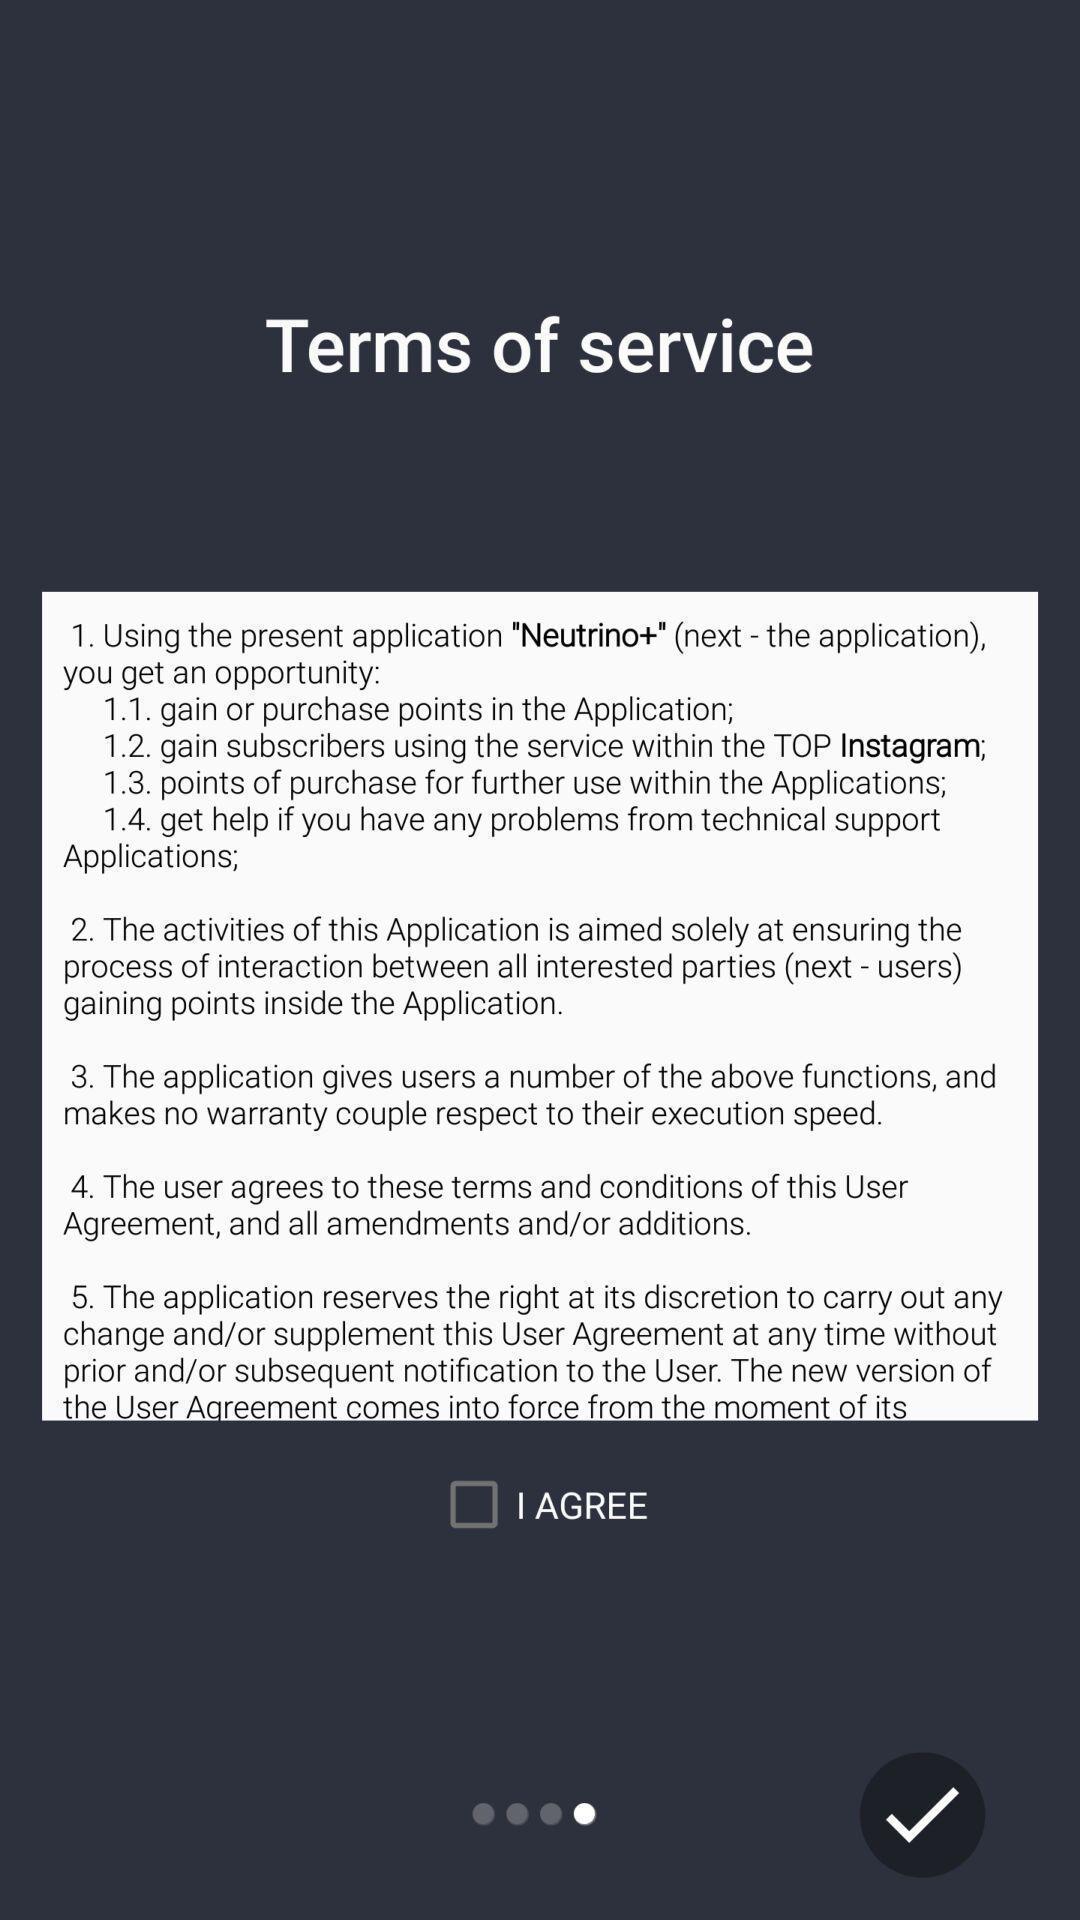Give me a narrative description of this picture. Pop-up showing the terms and conditions. 